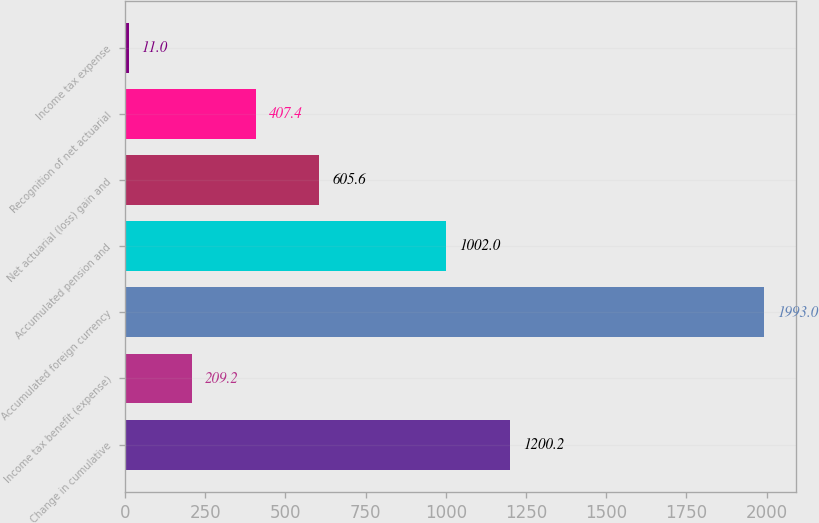Convert chart to OTSL. <chart><loc_0><loc_0><loc_500><loc_500><bar_chart><fcel>Change in cumulative<fcel>Income tax benefit (expense)<fcel>Accumulated foreign currency<fcel>Accumulated pension and<fcel>Net actuarial (loss) gain and<fcel>Recognition of net actuarial<fcel>Income tax expense<nl><fcel>1200.2<fcel>209.2<fcel>1993<fcel>1002<fcel>605.6<fcel>407.4<fcel>11<nl></chart> 